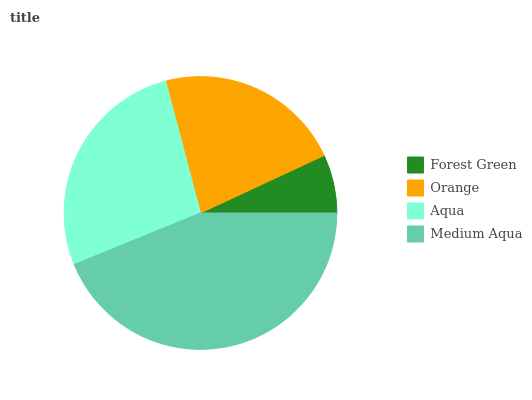Is Forest Green the minimum?
Answer yes or no. Yes. Is Medium Aqua the maximum?
Answer yes or no. Yes. Is Orange the minimum?
Answer yes or no. No. Is Orange the maximum?
Answer yes or no. No. Is Orange greater than Forest Green?
Answer yes or no. Yes. Is Forest Green less than Orange?
Answer yes or no. Yes. Is Forest Green greater than Orange?
Answer yes or no. No. Is Orange less than Forest Green?
Answer yes or no. No. Is Aqua the high median?
Answer yes or no. Yes. Is Orange the low median?
Answer yes or no. Yes. Is Medium Aqua the high median?
Answer yes or no. No. Is Aqua the low median?
Answer yes or no. No. 